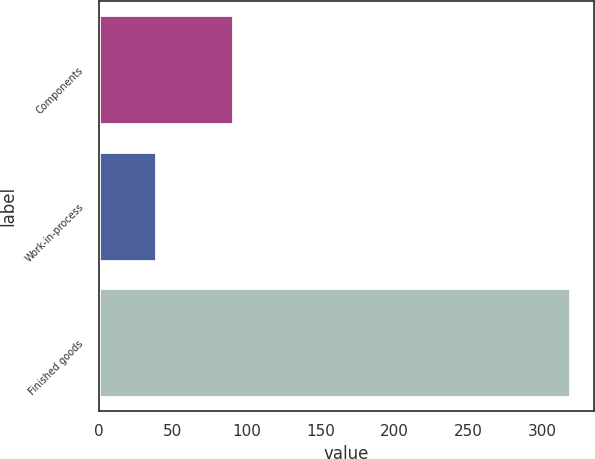Convert chart to OTSL. <chart><loc_0><loc_0><loc_500><loc_500><bar_chart><fcel>Components<fcel>Work-in-process<fcel>Finished goods<nl><fcel>91<fcel>39<fcel>319<nl></chart> 